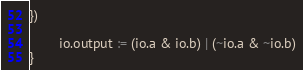<code> <loc_0><loc_0><loc_500><loc_500><_Scala_>})

		io.output := (io.a & io.b) | (~io.a & ~io.b)
}
</code> 